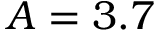<formula> <loc_0><loc_0><loc_500><loc_500>A = 3 . 7</formula> 